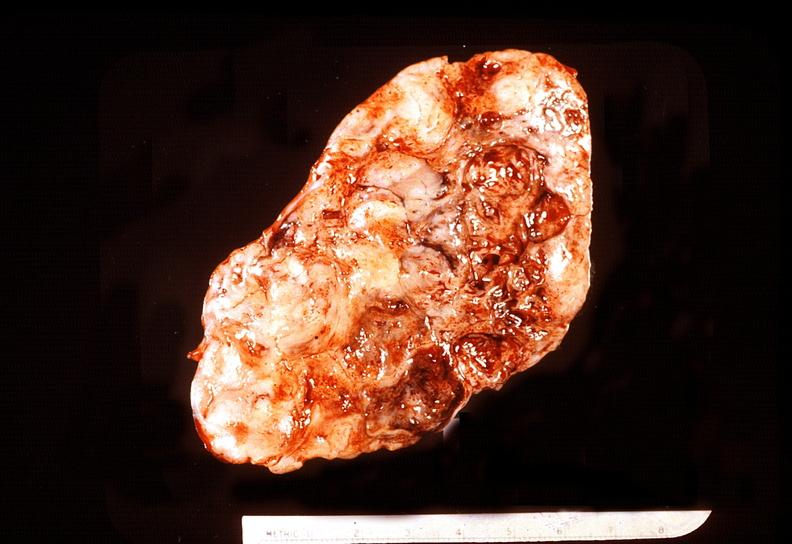what does this image show?
Answer the question using a single word or phrase. Adrenal phaeochromocytoma 